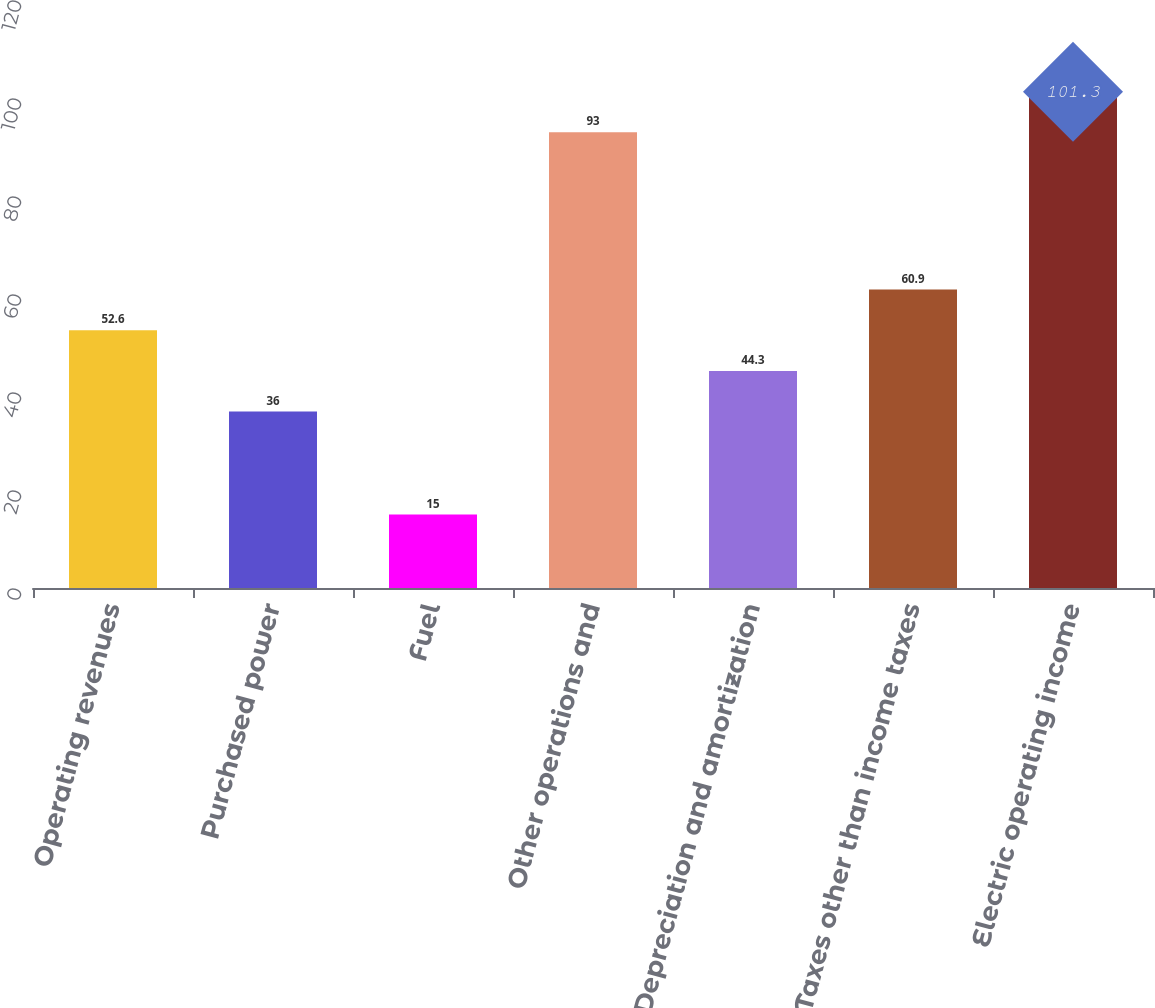Convert chart to OTSL. <chart><loc_0><loc_0><loc_500><loc_500><bar_chart><fcel>Operating revenues<fcel>Purchased power<fcel>Fuel<fcel>Other operations and<fcel>Depreciation and amortization<fcel>Taxes other than income taxes<fcel>Electric operating income<nl><fcel>52.6<fcel>36<fcel>15<fcel>93<fcel>44.3<fcel>60.9<fcel>101.3<nl></chart> 